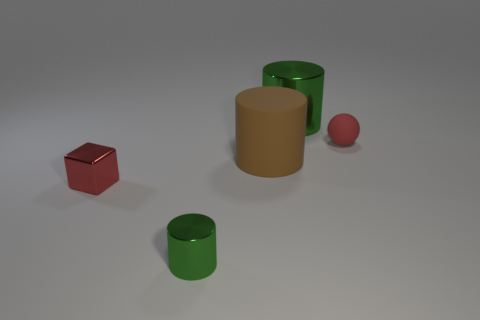There is a thing that is the same color as the small matte ball; what is it made of?
Your response must be concise. Metal. Are there fewer small things in front of the sphere than things?
Keep it short and to the point. Yes. Is the size of the metallic block the same as the brown cylinder?
Offer a very short reply. No. What size is the red cube that is made of the same material as the small green object?
Ensure brevity in your answer.  Small. What number of metal objects have the same color as the matte ball?
Offer a very short reply. 1. Are there fewer red metal blocks that are behind the big matte thing than matte balls that are behind the red matte thing?
Provide a short and direct response. No. Does the green metal object behind the small green metallic object have the same shape as the brown rubber object?
Keep it short and to the point. Yes. Is the green thing on the right side of the tiny green metallic cylinder made of the same material as the large brown cylinder?
Provide a short and direct response. No. There is a green cylinder that is in front of the green metal object behind the metallic cylinder that is in front of the red matte object; what is it made of?
Ensure brevity in your answer.  Metal. How many other things are there of the same shape as the large brown object?
Keep it short and to the point. 2. 